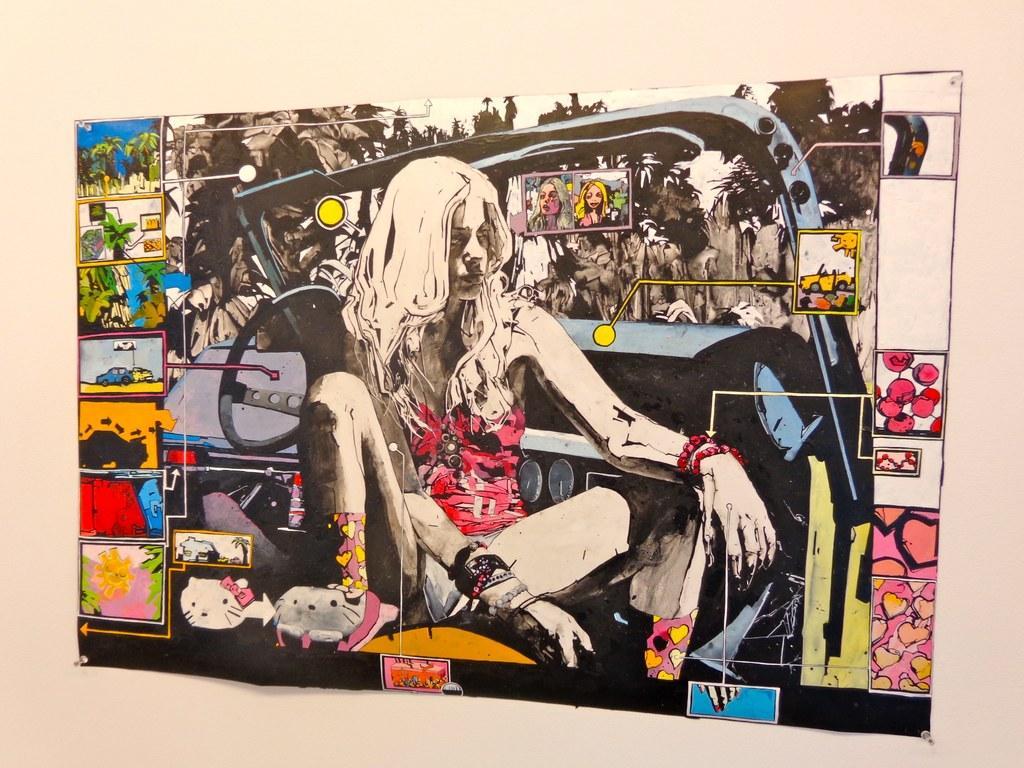Describe this image in one or two sentences. In this picture I can see a painted paper sticked to the wall, on which I can see a woman and some painted pictures. 